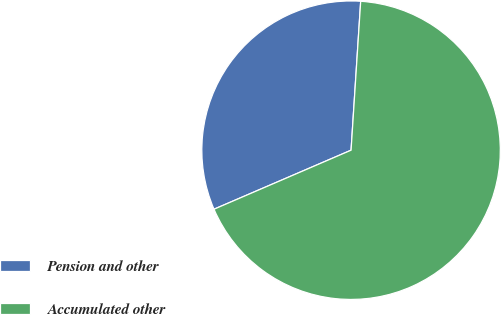Convert chart to OTSL. <chart><loc_0><loc_0><loc_500><loc_500><pie_chart><fcel>Pension and other<fcel>Accumulated other<nl><fcel>32.5%<fcel>67.5%<nl></chart> 